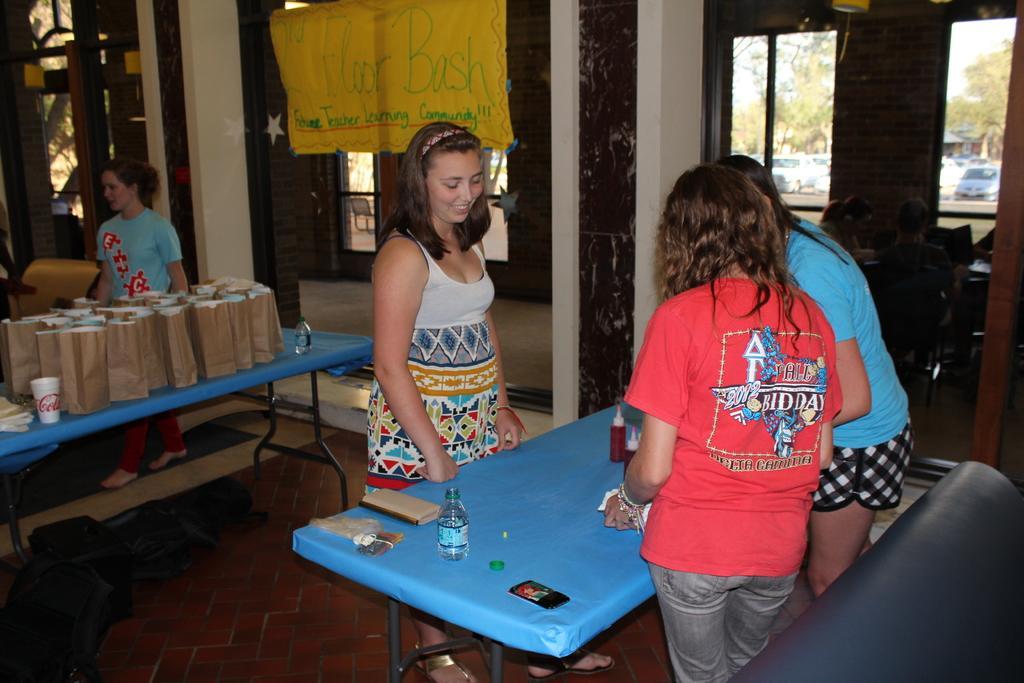Please provide a concise description of this image. This three women are standing beside this table, on this table there are bottles, mobile and book. Far a woman is standing back side of this table, on this table there are bags, bottle and cup. A banner is attached to the pillars. From this window we can able to see vehicles and trees. Far these persons are sitting on chairs. 